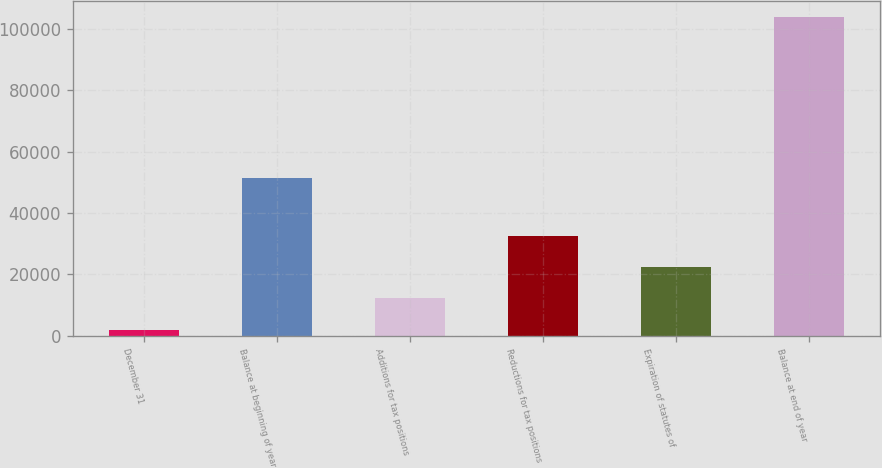Convert chart. <chart><loc_0><loc_0><loc_500><loc_500><bar_chart><fcel>December 31<fcel>Balance at beginning of year<fcel>Additions for tax positions<fcel>Reductions for tax positions<fcel>Expiration of statutes of<fcel>Balance at end of year<nl><fcel>2013<fcel>51520<fcel>12208<fcel>32598<fcel>22403<fcel>103963<nl></chart> 